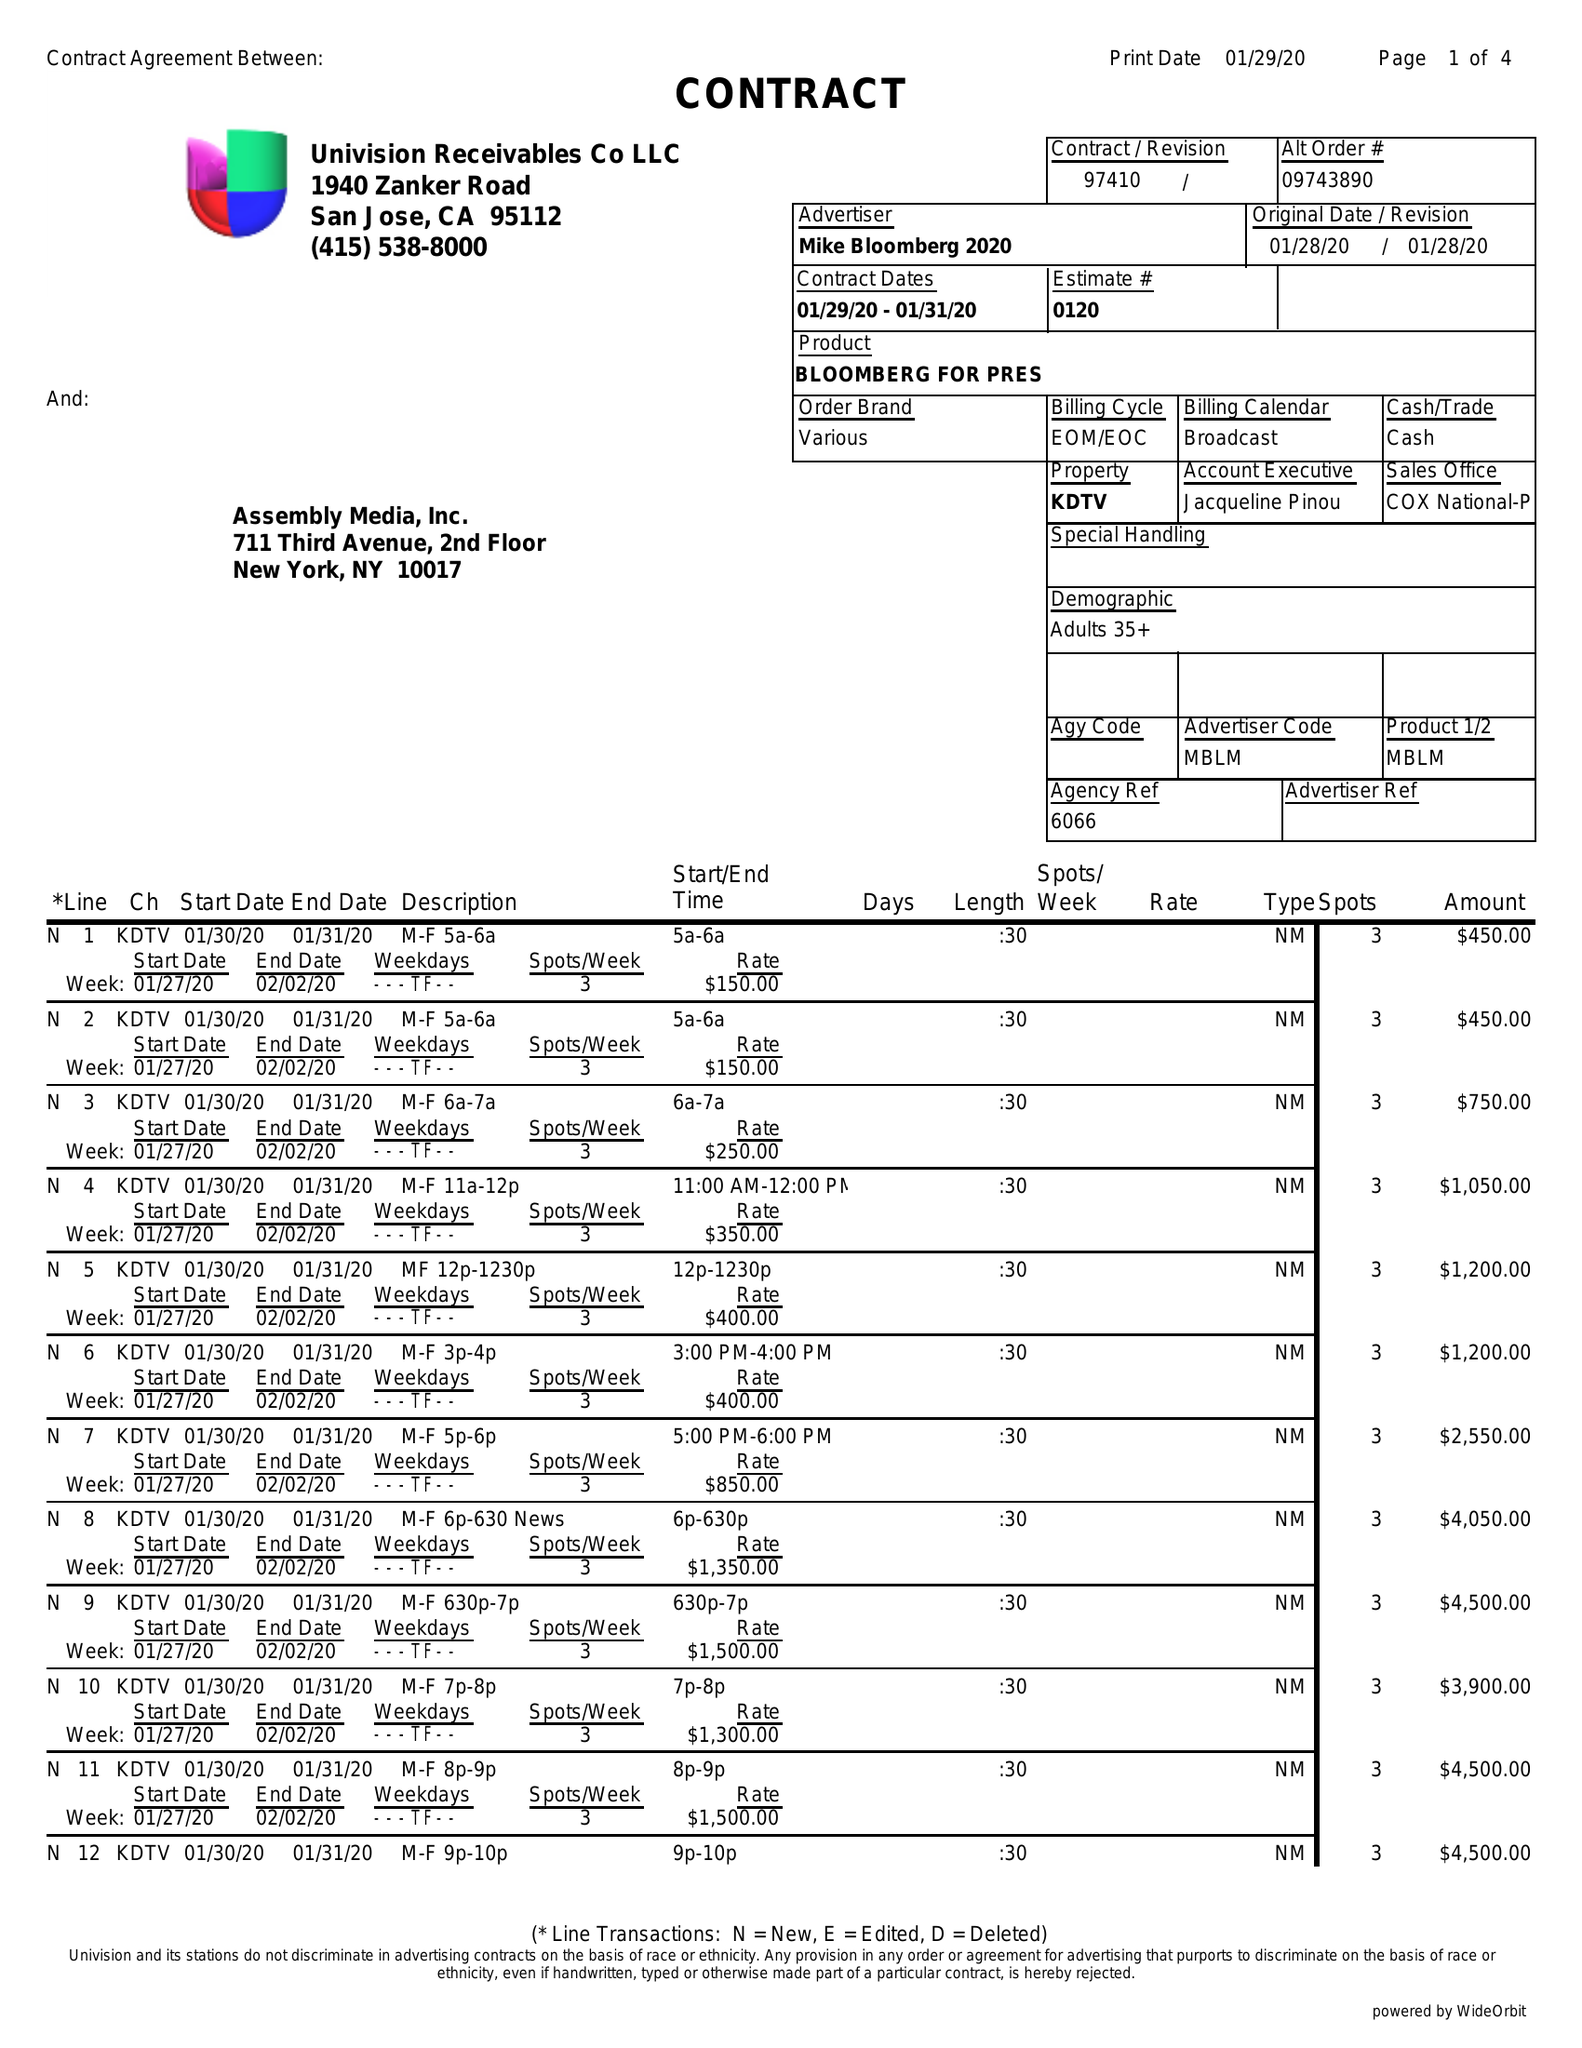What is the value for the gross_amount?
Answer the question using a single word or phrase. 42150.00 